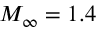<formula> <loc_0><loc_0><loc_500><loc_500>M _ { \infty } = 1 . 4</formula> 